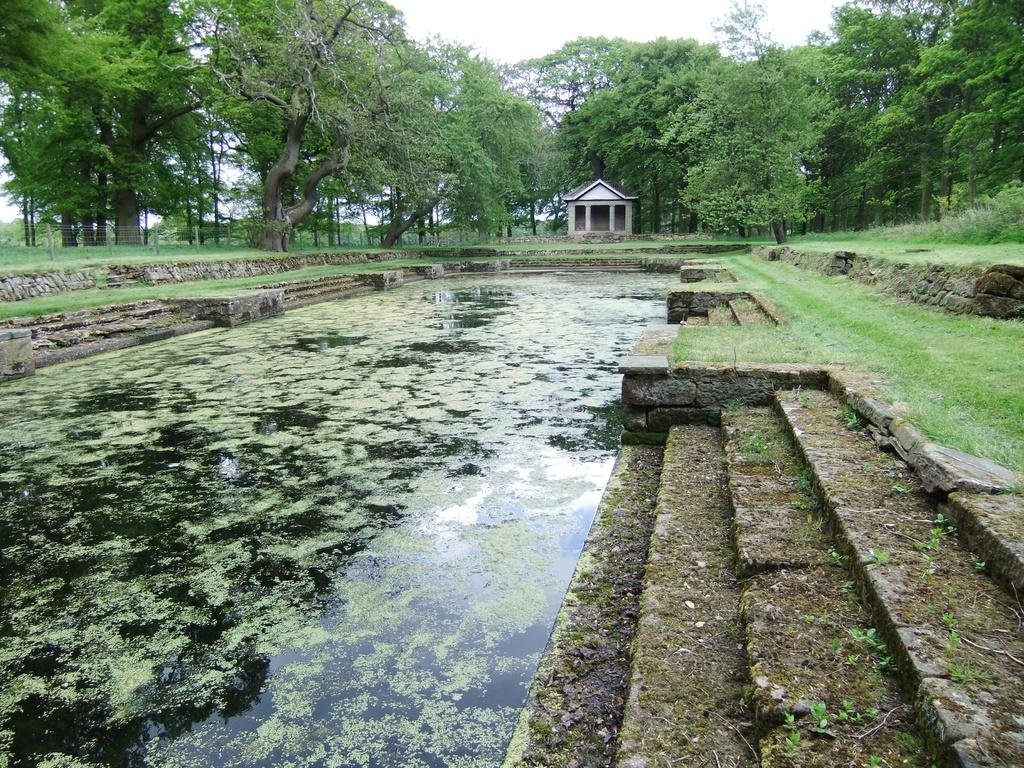What is the main feature in the center of the image? There is a pond in the center of the image. What can be seen in the background of the image? There is a shed and trees in the background of the image. What is on the left side of the image? There is a fence on the left side of the image. Are there any architectural features in the image? Yes, there are stairs in the image. What is visible at the top of the image? The sky is visible at the top of the image. What type of tin is being used toasted on the slope in the image? There is no tin or slope present in the image; it features a pond, shed, trees, fence, stairs, and sky. 